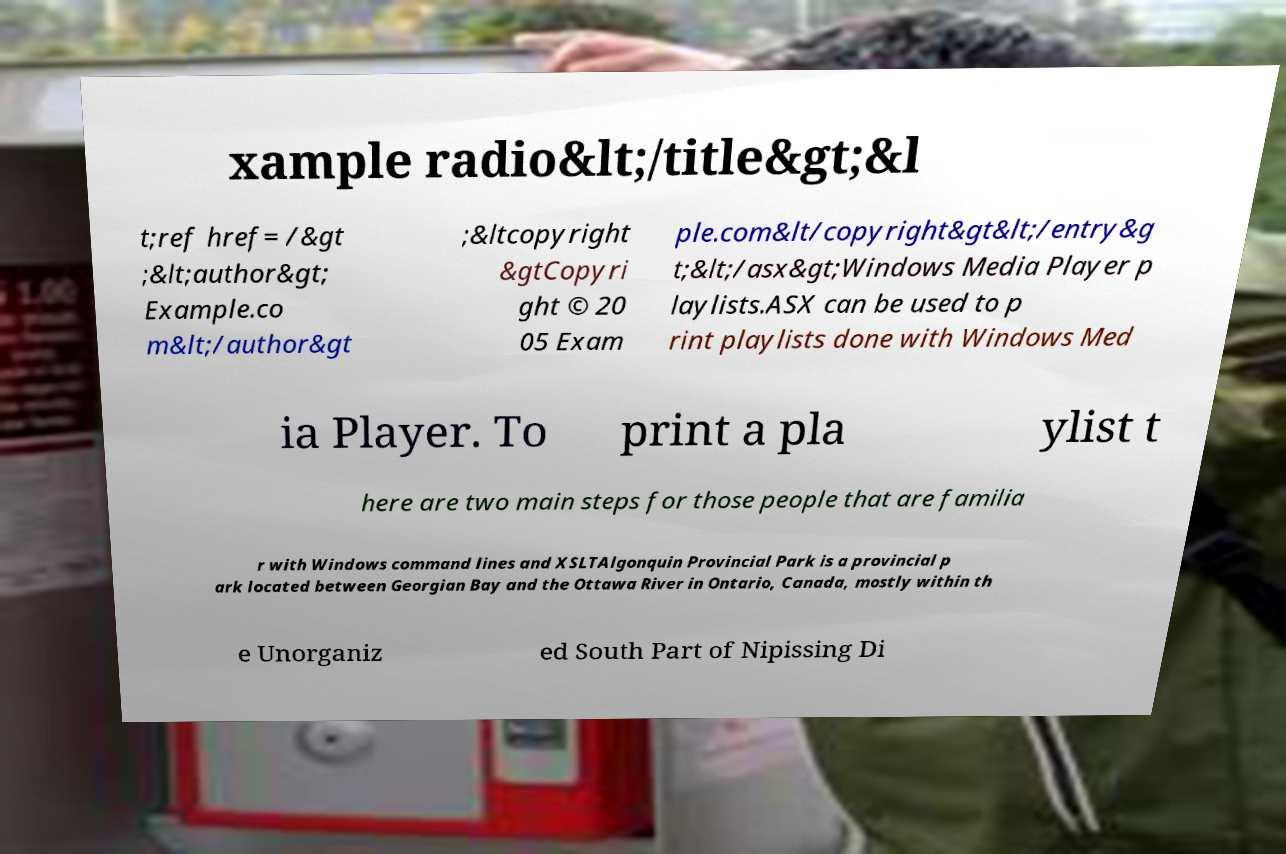Please identify and transcribe the text found in this image. xample radio&lt;/title&gt;&l t;ref href= /&gt ;&lt;author&gt; Example.co m&lt;/author&gt ;&ltcopyright &gtCopyri ght © 20 05 Exam ple.com&lt/copyright&gt&lt;/entry&g t;&lt;/asx&gt;Windows Media Player p laylists.ASX can be used to p rint playlists done with Windows Med ia Player. To print a pla ylist t here are two main steps for those people that are familia r with Windows command lines and XSLTAlgonquin Provincial Park is a provincial p ark located between Georgian Bay and the Ottawa River in Ontario, Canada, mostly within th e Unorganiz ed South Part of Nipissing Di 